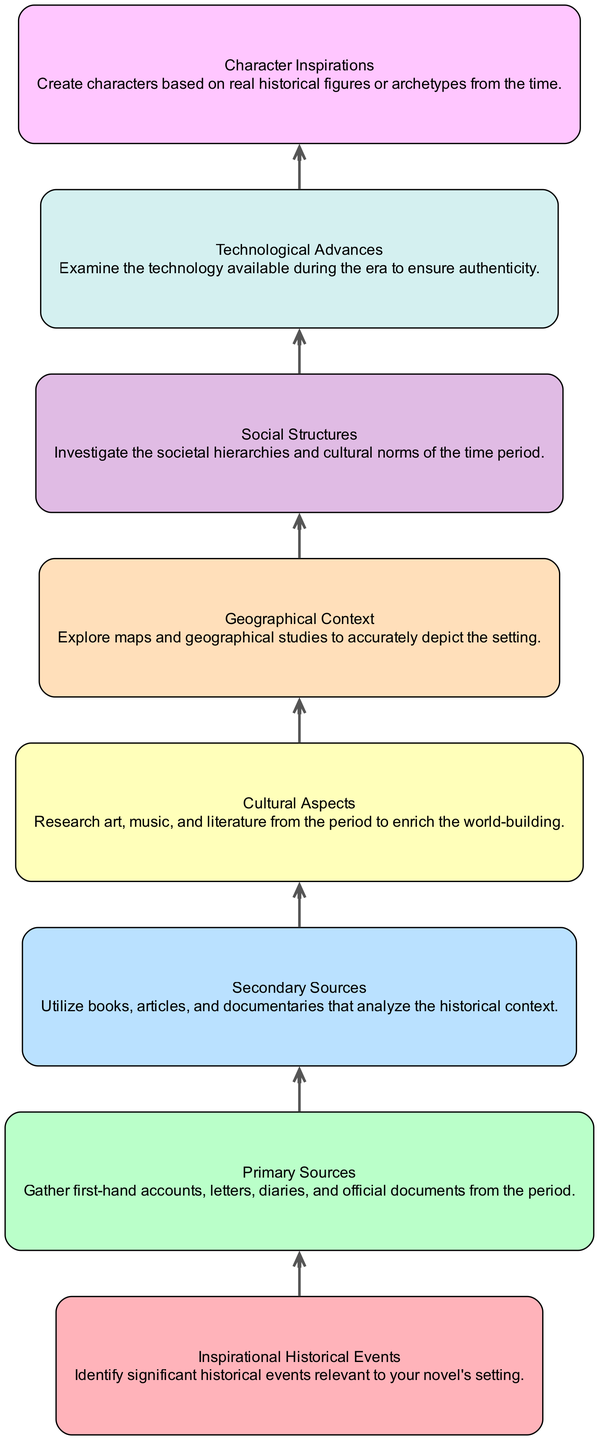What is the top-most element in the diagram? The top-most element in a Bottom Up Flow Chart is the last element listed in the flow, which is 'Character Inspirations,' as it references the foundational aspects that inform character creation based on historical context.
Answer: Character Inspirations How many total elements are in the diagram? By counting the individual elements defined in the data, we find there are 8 elements representing different aspects of historical research for world-building.
Answer: 8 Which element directly precedes 'Cultural Aspects'? To find the element that precedes 'Cultural Aspects,' we examine the flow and see that 'Secondary Sources' comes right before it in the sequence of elements.
Answer: Secondary Sources What is the relationship between 'Technological Advances' and 'Social Structures'? In the diagram, 'Technological Advances' and 'Social Structures' are sequential elements, meaning 'Technological Advances' informs the subsequent understanding of 'Social Structures,' reflecting a flow from examining technology to analyzing societal norms.
Answer: Sequential Which element follows 'Primary Sources'? By checking the flow of elements, we note that 'Secondary Sources' follows immediately after 'Primary Sources' in the diagram's structure.
Answer: Secondary Sources How many directional edges are in the diagram? Each of the 8 elements, except for the last one, has a directed edge leading to the next element, so there are a total of 7 edges connecting all the elements in a flow from top to bottom.
Answer: 7 What kind of research does 'Inspirational Historical Events' influence? 'Inspirational Historical Events' influences several subsequent elements, particularly 'Primary Sources' and 'Character Inspirations,' as they are based on such events and contexts.
Answer: Primary Sources and Character Inspirations What does the bottom-most element represent? The bottom-most element in a Bottom Up Flow Chart summarizes the culmination of all previous research, represented here as 'Character Inspirations,' indicating the derived insights used for developing characters.
Answer: Character Inspirations Which element is nearest to 'Geographical Context'? 'Cultural Aspects' is the nearest element to 'Geographical Context' in this diagram, as they are arranged adjacent to one another, showcasing the correlation between geography and cultural elements in historical research.
Answer: Cultural Aspects 